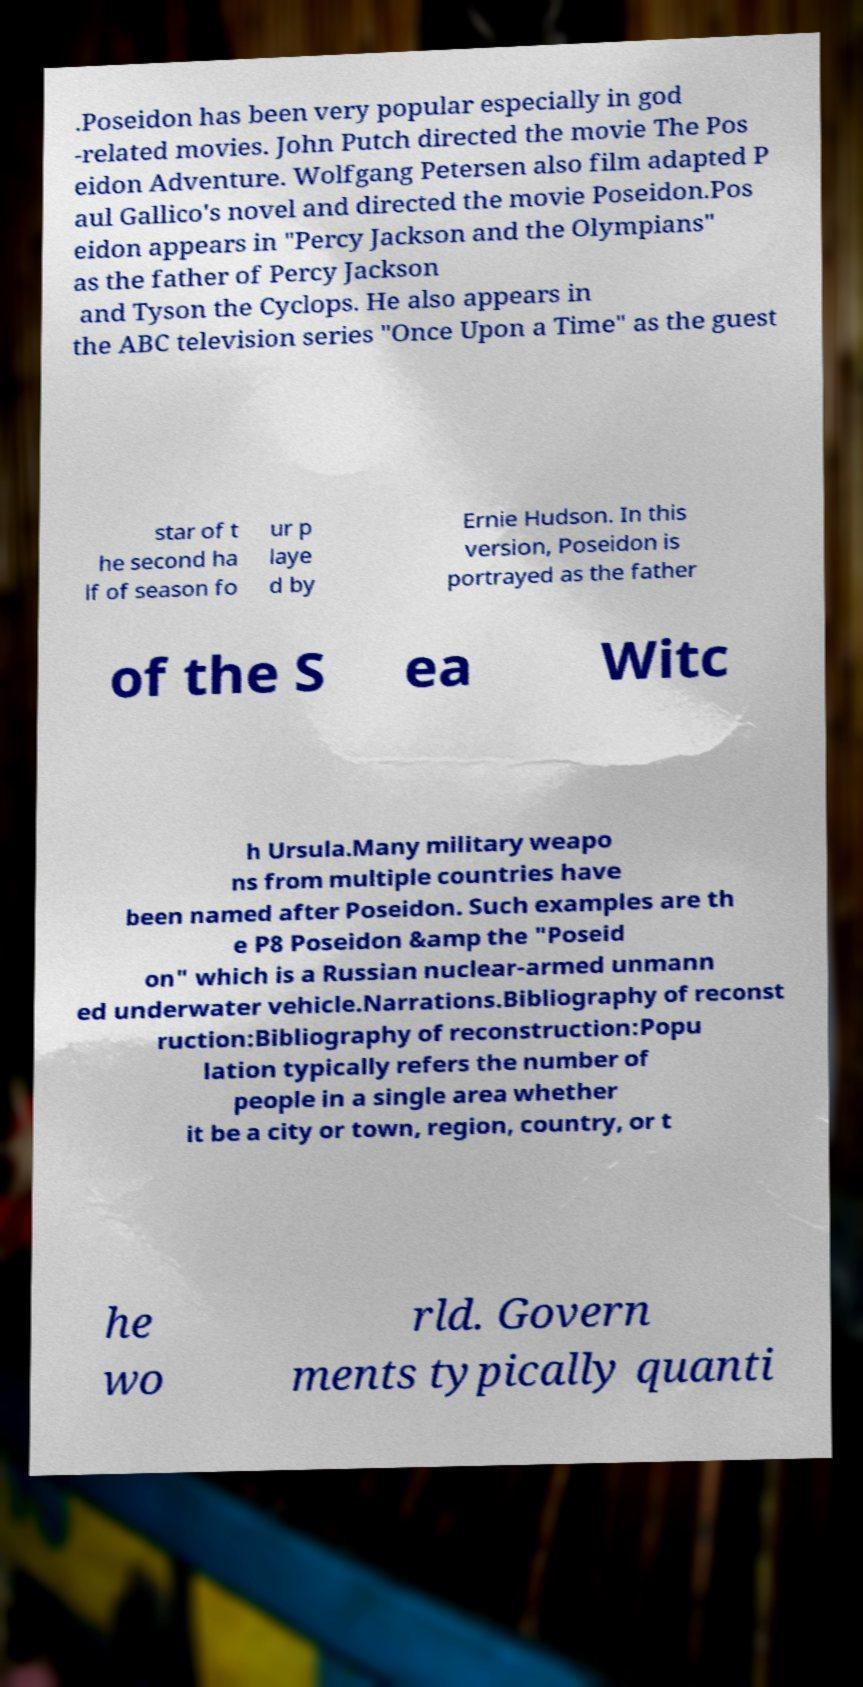Please identify and transcribe the text found in this image. .Poseidon has been very popular especially in god -related movies. John Putch directed the movie The Pos eidon Adventure. Wolfgang Petersen also film adapted P aul Gallico's novel and directed the movie Poseidon.Pos eidon appears in "Percy Jackson and the Olympians" as the father of Percy Jackson and Tyson the Cyclops. He also appears in the ABC television series "Once Upon a Time" as the guest star of t he second ha lf of season fo ur p laye d by Ernie Hudson. In this version, Poseidon is portrayed as the father of the S ea Witc h Ursula.Many military weapo ns from multiple countries have been named after Poseidon. Such examples are th e P8 Poseidon &amp the "Poseid on" which is a Russian nuclear-armed unmann ed underwater vehicle.Narrations.Bibliography of reconst ruction:Bibliography of reconstruction:Popu lation typically refers the number of people in a single area whether it be a city or town, region, country, or t he wo rld. Govern ments typically quanti 